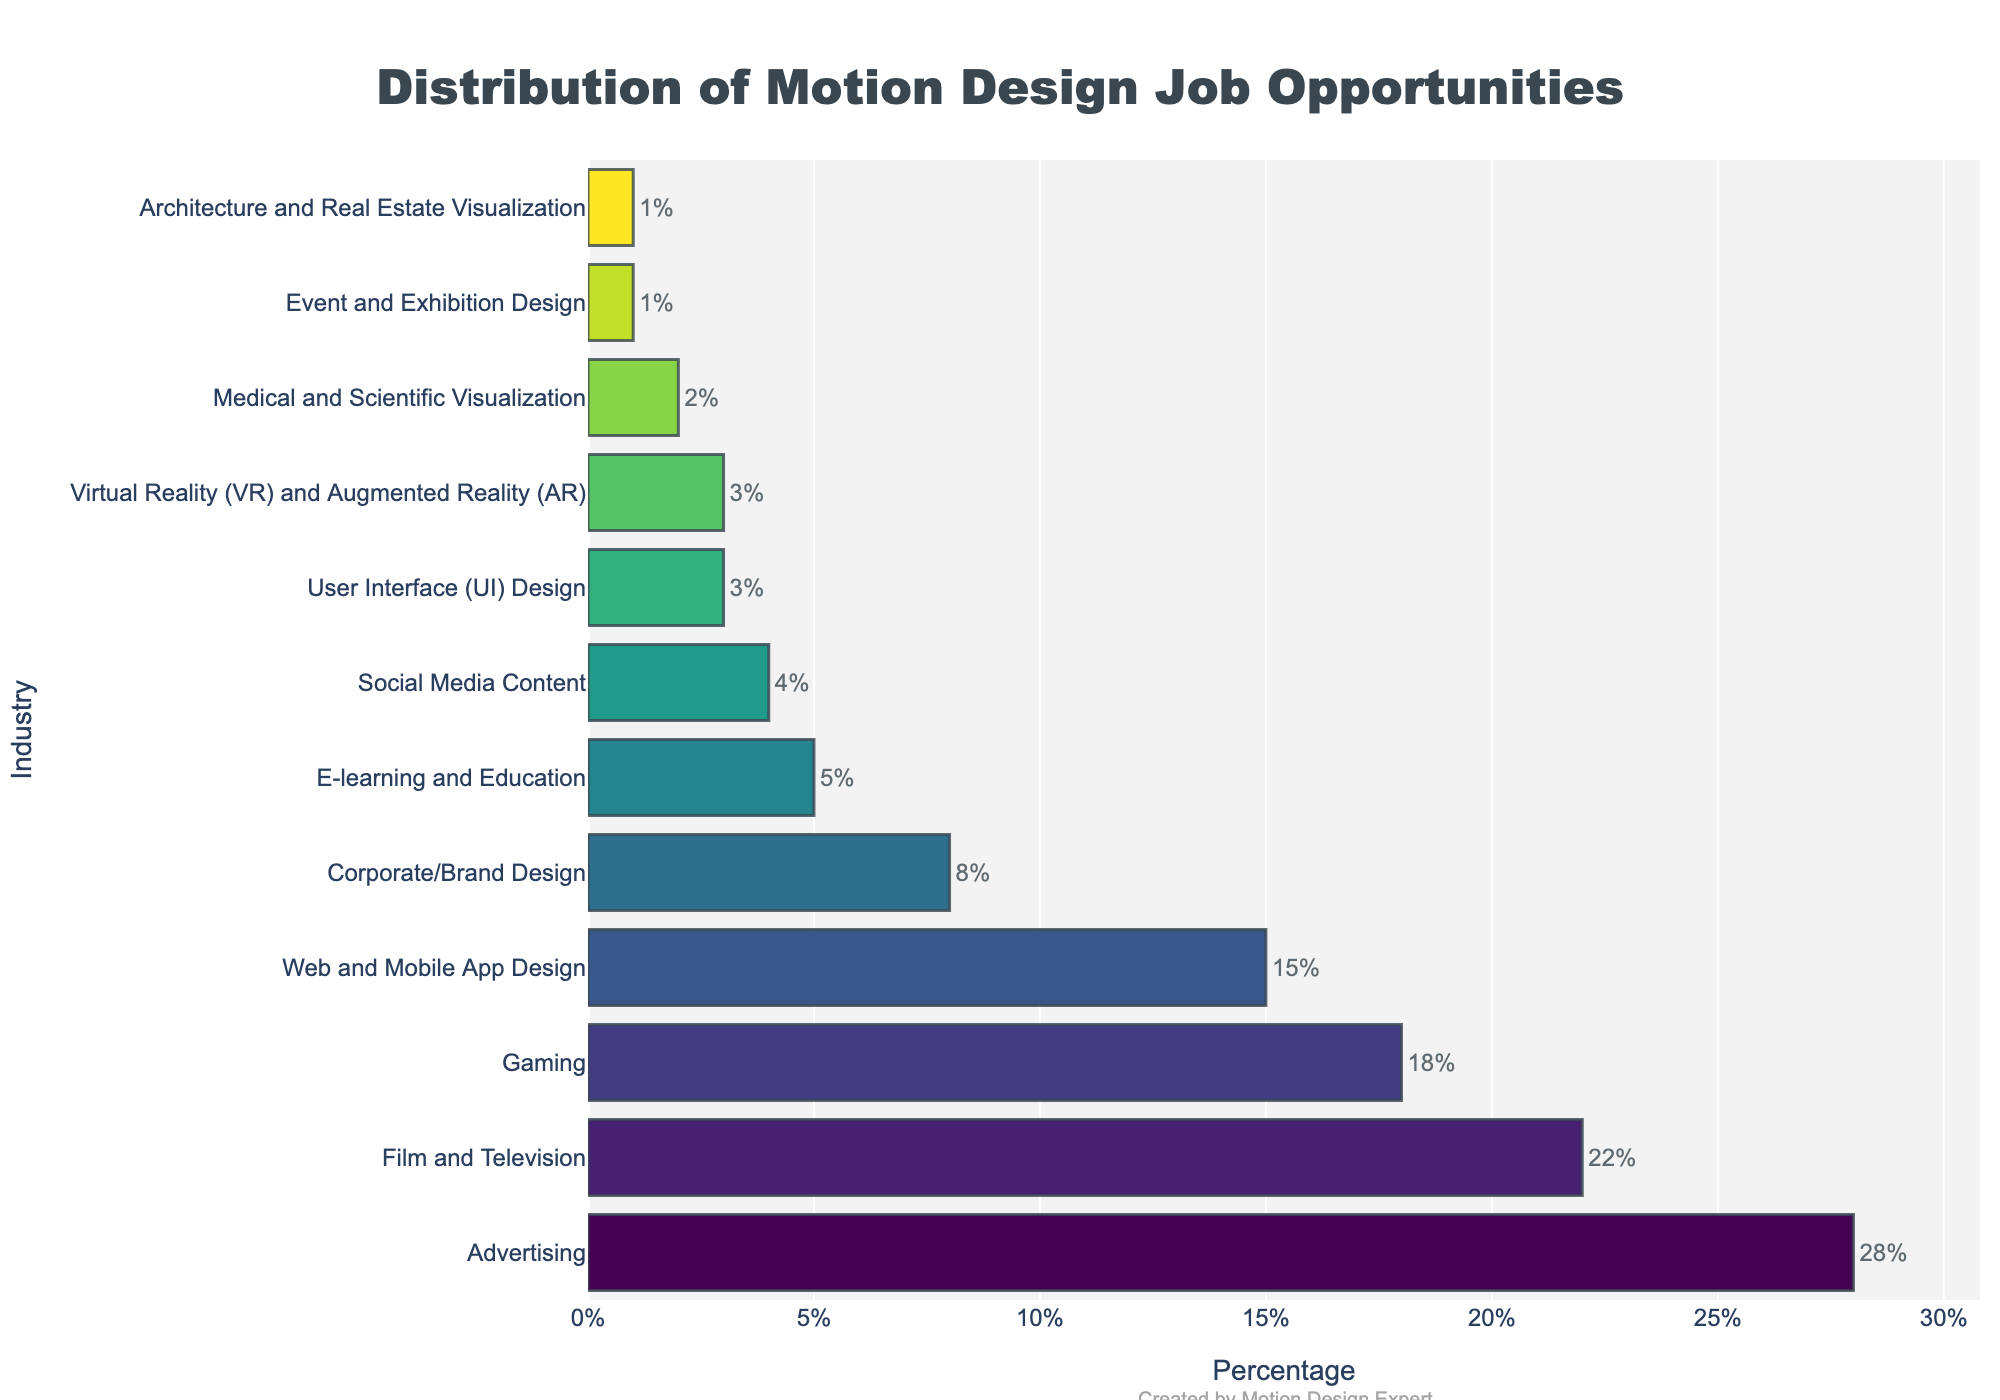Which industry has the highest percentage of motion design job opportunities? The bar chart shows that the Advertising industry has the longest bar, indicating the highest percentage. Therefore, the Advertising industry has the highest percentage of motion design job opportunities.
Answer: Advertising What is the combined percentage of job opportunities in Film and Television, and Gaming industries? The Film and Television industry has 22%, and the Gaming industry has 18%. Adding these together, 22% + 18% equals 40%.
Answer: 40% How does the percentage of opportunities in Corporate/Brand Design compare to that in Web and Mobile App Design? The Corporate/Brand Design industry has 8%, while Web and Mobile App Design has 15%. By comparison, Web and Mobile App Design has a higher percentage.
Answer: Web and Mobile App Design is higher by 7% Which industries have a lower percentage of job opportunities than E-learning and Education? E-learning and Education has 5%. The industries with lower percentages are Social Media Content (4%), User Interface (UI) Design (3%), Virtual Reality (VR) and Augmented Reality (AR) (3%), Medical and Scientific Visualization (2%), Event and Exhibition Design (1%), and Architecture and Real Estate Visualization (1%).
Answer: Social Media Content, UI Design, VR/AR, Medical and Scientific Visualization, Event and Exhibition Design, Architecture and Real Estate Visualization What is the average percentage of job opportunities across all industries listed in the chart? To find the average, add all the percentages together and divide by the number of industries. The sum is 28 + 22 + 18 + 15 + 8 + 5 + 4 + 3 + 3 + 2 + 1 + 1, which equals 110. Dividing by the number of industries (12) gives 110/12, which is approximately 9.17%.
Answer: Approximately 9.17% What's the difference in job opportunities between the top two industries? The Advertising industry has 28%, and the Film and Television industry has 22%. Subtracting the second from the first, 28% - 22% equals 6%.
Answer: 6% List the top three industries in descending order of job opportunities. According to the bar chart, the top three industries are Advertising (28%), Film and Television (22%), and Gaming (18%).
Answer: Advertising, Film and Television, Gaming Which of the industries occupy the middle position in terms of job opportunities? When sorted in descending order, the industries are listed as follows (with positions noted): Advertising (1), Film and Television (2), Gaming (3), Web and Mobile App Design (4), Corporate/Brand Design (5), E-learning and Education (6), Social Media Content (7), User Interface (UI) Design (8), Virtual Reality (VR) and Augmented Reality (AR) (9), Medical and Scientific Visualization (10), Event and Exhibition Design (11), Architecture and Real Estate Visualization (12). The middle position is the 6th industry: E-learning and Education.
Answer: E-learning and Education 